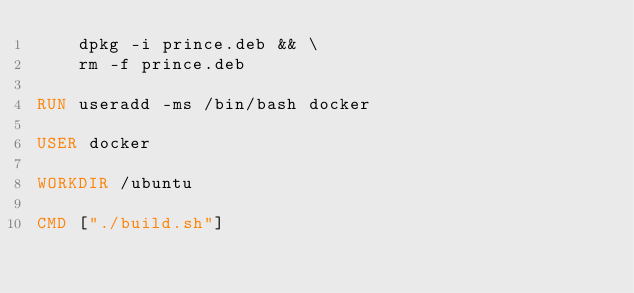Convert code to text. <code><loc_0><loc_0><loc_500><loc_500><_Dockerfile_>    dpkg -i prince.deb && \
    rm -f prince.deb

RUN useradd -ms /bin/bash docker

USER docker

WORKDIR /ubuntu

CMD ["./build.sh"]
</code> 